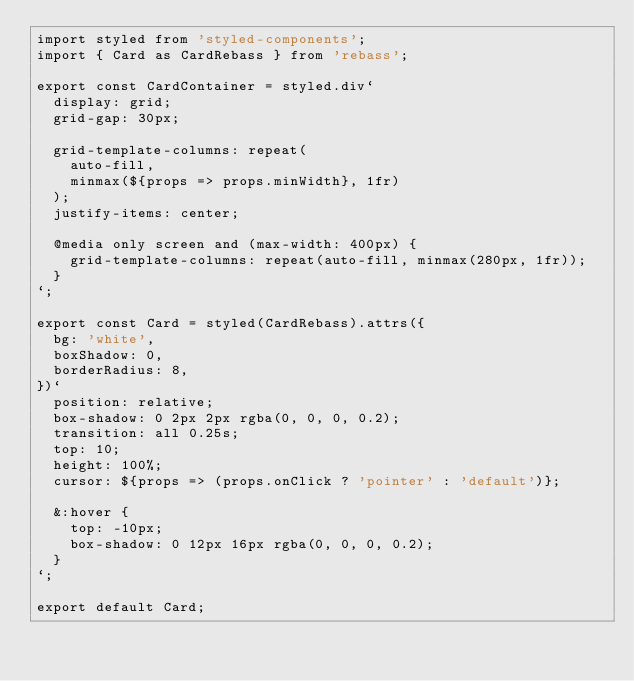<code> <loc_0><loc_0><loc_500><loc_500><_JavaScript_>import styled from 'styled-components';
import { Card as CardRebass } from 'rebass';

export const CardContainer = styled.div`
  display: grid;
  grid-gap: 30px;

  grid-template-columns: repeat(
    auto-fill,
    minmax(${props => props.minWidth}, 1fr)
  );
  justify-items: center;

  @media only screen and (max-width: 400px) {
    grid-template-columns: repeat(auto-fill, minmax(280px, 1fr));
  }
`;

export const Card = styled(CardRebass).attrs({
  bg: 'white',
  boxShadow: 0,
  borderRadius: 8,
})`
  position: relative;
  box-shadow: 0 2px 2px rgba(0, 0, 0, 0.2);
  transition: all 0.25s;
  top: 10;
  height: 100%;
  cursor: ${props => (props.onClick ? 'pointer' : 'default')};

  &:hover {
    top: -10px;
    box-shadow: 0 12px 16px rgba(0, 0, 0, 0.2);
  }
`;

export default Card;
</code> 